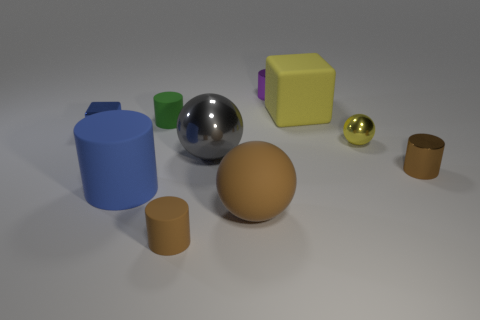Subtract all purple spheres. How many brown cylinders are left? 2 Subtract all small purple cylinders. How many cylinders are left? 4 Subtract 1 cylinders. How many cylinders are left? 4 Subtract all purple cylinders. How many cylinders are left? 4 Subtract all balls. How many objects are left? 7 Subtract all blue cylinders. Subtract all yellow blocks. How many cylinders are left? 4 Add 2 tiny matte cubes. How many tiny matte cubes exist? 2 Subtract 0 cyan blocks. How many objects are left? 10 Subtract all tiny cylinders. Subtract all green matte things. How many objects are left? 5 Add 9 large yellow cubes. How many large yellow cubes are left? 10 